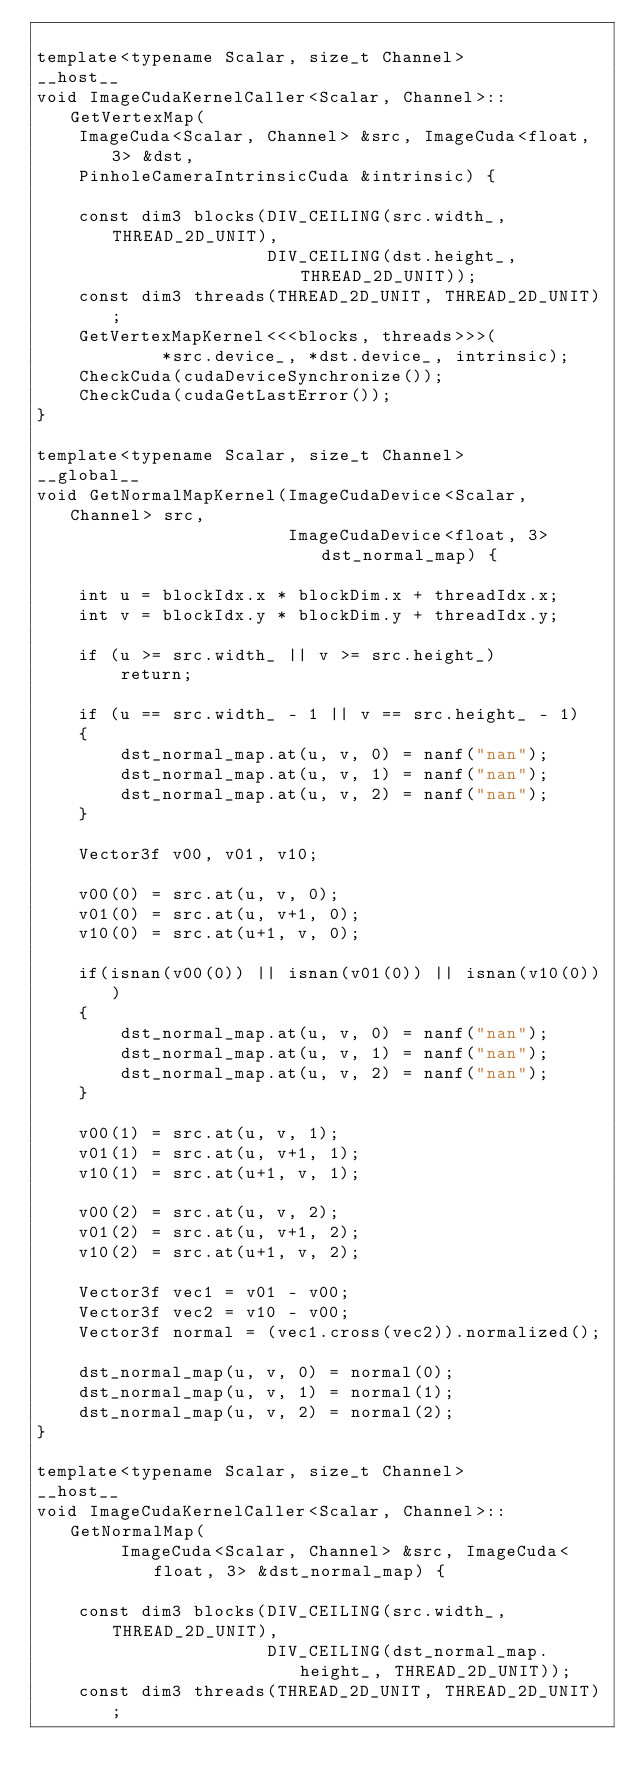<code> <loc_0><loc_0><loc_500><loc_500><_Cuda_>
template<typename Scalar, size_t Channel>
__host__
void ImageCudaKernelCaller<Scalar, Channel>::GetVertexMap(
    ImageCuda<Scalar, Channel> &src, ImageCuda<float, 3> &dst,
    PinholeCameraIntrinsicCuda &intrinsic) {

    const dim3 blocks(DIV_CEILING(src.width_, THREAD_2D_UNIT),
                      DIV_CEILING(dst.height_, THREAD_2D_UNIT));
    const dim3 threads(THREAD_2D_UNIT, THREAD_2D_UNIT);
    GetVertexMapKernel<<<blocks, threads>>>(
            *src.device_, *dst.device_, intrinsic);
    CheckCuda(cudaDeviceSynchronize());
    CheckCuda(cudaGetLastError());
}

template<typename Scalar, size_t Channel>
__global__
void GetNormalMapKernel(ImageCudaDevice<Scalar, Channel> src,
                        ImageCudaDevice<float, 3> dst_normal_map) {

    int u = blockIdx.x * blockDim.x + threadIdx.x;
    int v = blockIdx.y * blockDim.y + threadIdx.y;

    if (u >= src.width_ || v >= src.height_)
        return;

    if (u == src.width_ - 1 || v == src.height_ - 1)
    {
        dst_normal_map.at(u, v, 0) = nanf("nan");
        dst_normal_map.at(u, v, 1) = nanf("nan");
        dst_normal_map.at(u, v, 2) = nanf("nan");
    }

    Vector3f v00, v01, v10;

    v00(0) = src.at(u, v, 0);
    v01(0) = src.at(u, v+1, 0);
    v10(0) = src.at(u+1, v, 0);

    if(isnan(v00(0)) || isnan(v01(0)) || isnan(v10(0)))
    {
        dst_normal_map.at(u, v, 0) = nanf("nan");
        dst_normal_map.at(u, v, 1) = nanf("nan");
        dst_normal_map.at(u, v, 2) = nanf("nan");
    }

    v00(1) = src.at(u, v, 1);
    v01(1) = src.at(u, v+1, 1);
    v10(1) = src.at(u+1, v, 1);

    v00(2) = src.at(u, v, 2);
    v01(2) = src.at(u, v+1, 2);
    v10(2) = src.at(u+1, v, 2);

    Vector3f vec1 = v01 - v00;
    Vector3f vec2 = v10 - v00;
    Vector3f normal = (vec1.cross(vec2)).normalized();

    dst_normal_map(u, v, 0) = normal(0);
    dst_normal_map(u, v, 1) = normal(1);
    dst_normal_map(u, v, 2) = normal(2);
}

template<typename Scalar, size_t Channel>
__host__
void ImageCudaKernelCaller<Scalar, Channel>::GetNormalMap(
        ImageCuda<Scalar, Channel> &src, ImageCuda<float, 3> &dst_normal_map) {

    const dim3 blocks(DIV_CEILING(src.width_, THREAD_2D_UNIT),
                      DIV_CEILING(dst_normal_map.height_, THREAD_2D_UNIT));
    const dim3 threads(THREAD_2D_UNIT, THREAD_2D_UNIT);</code> 